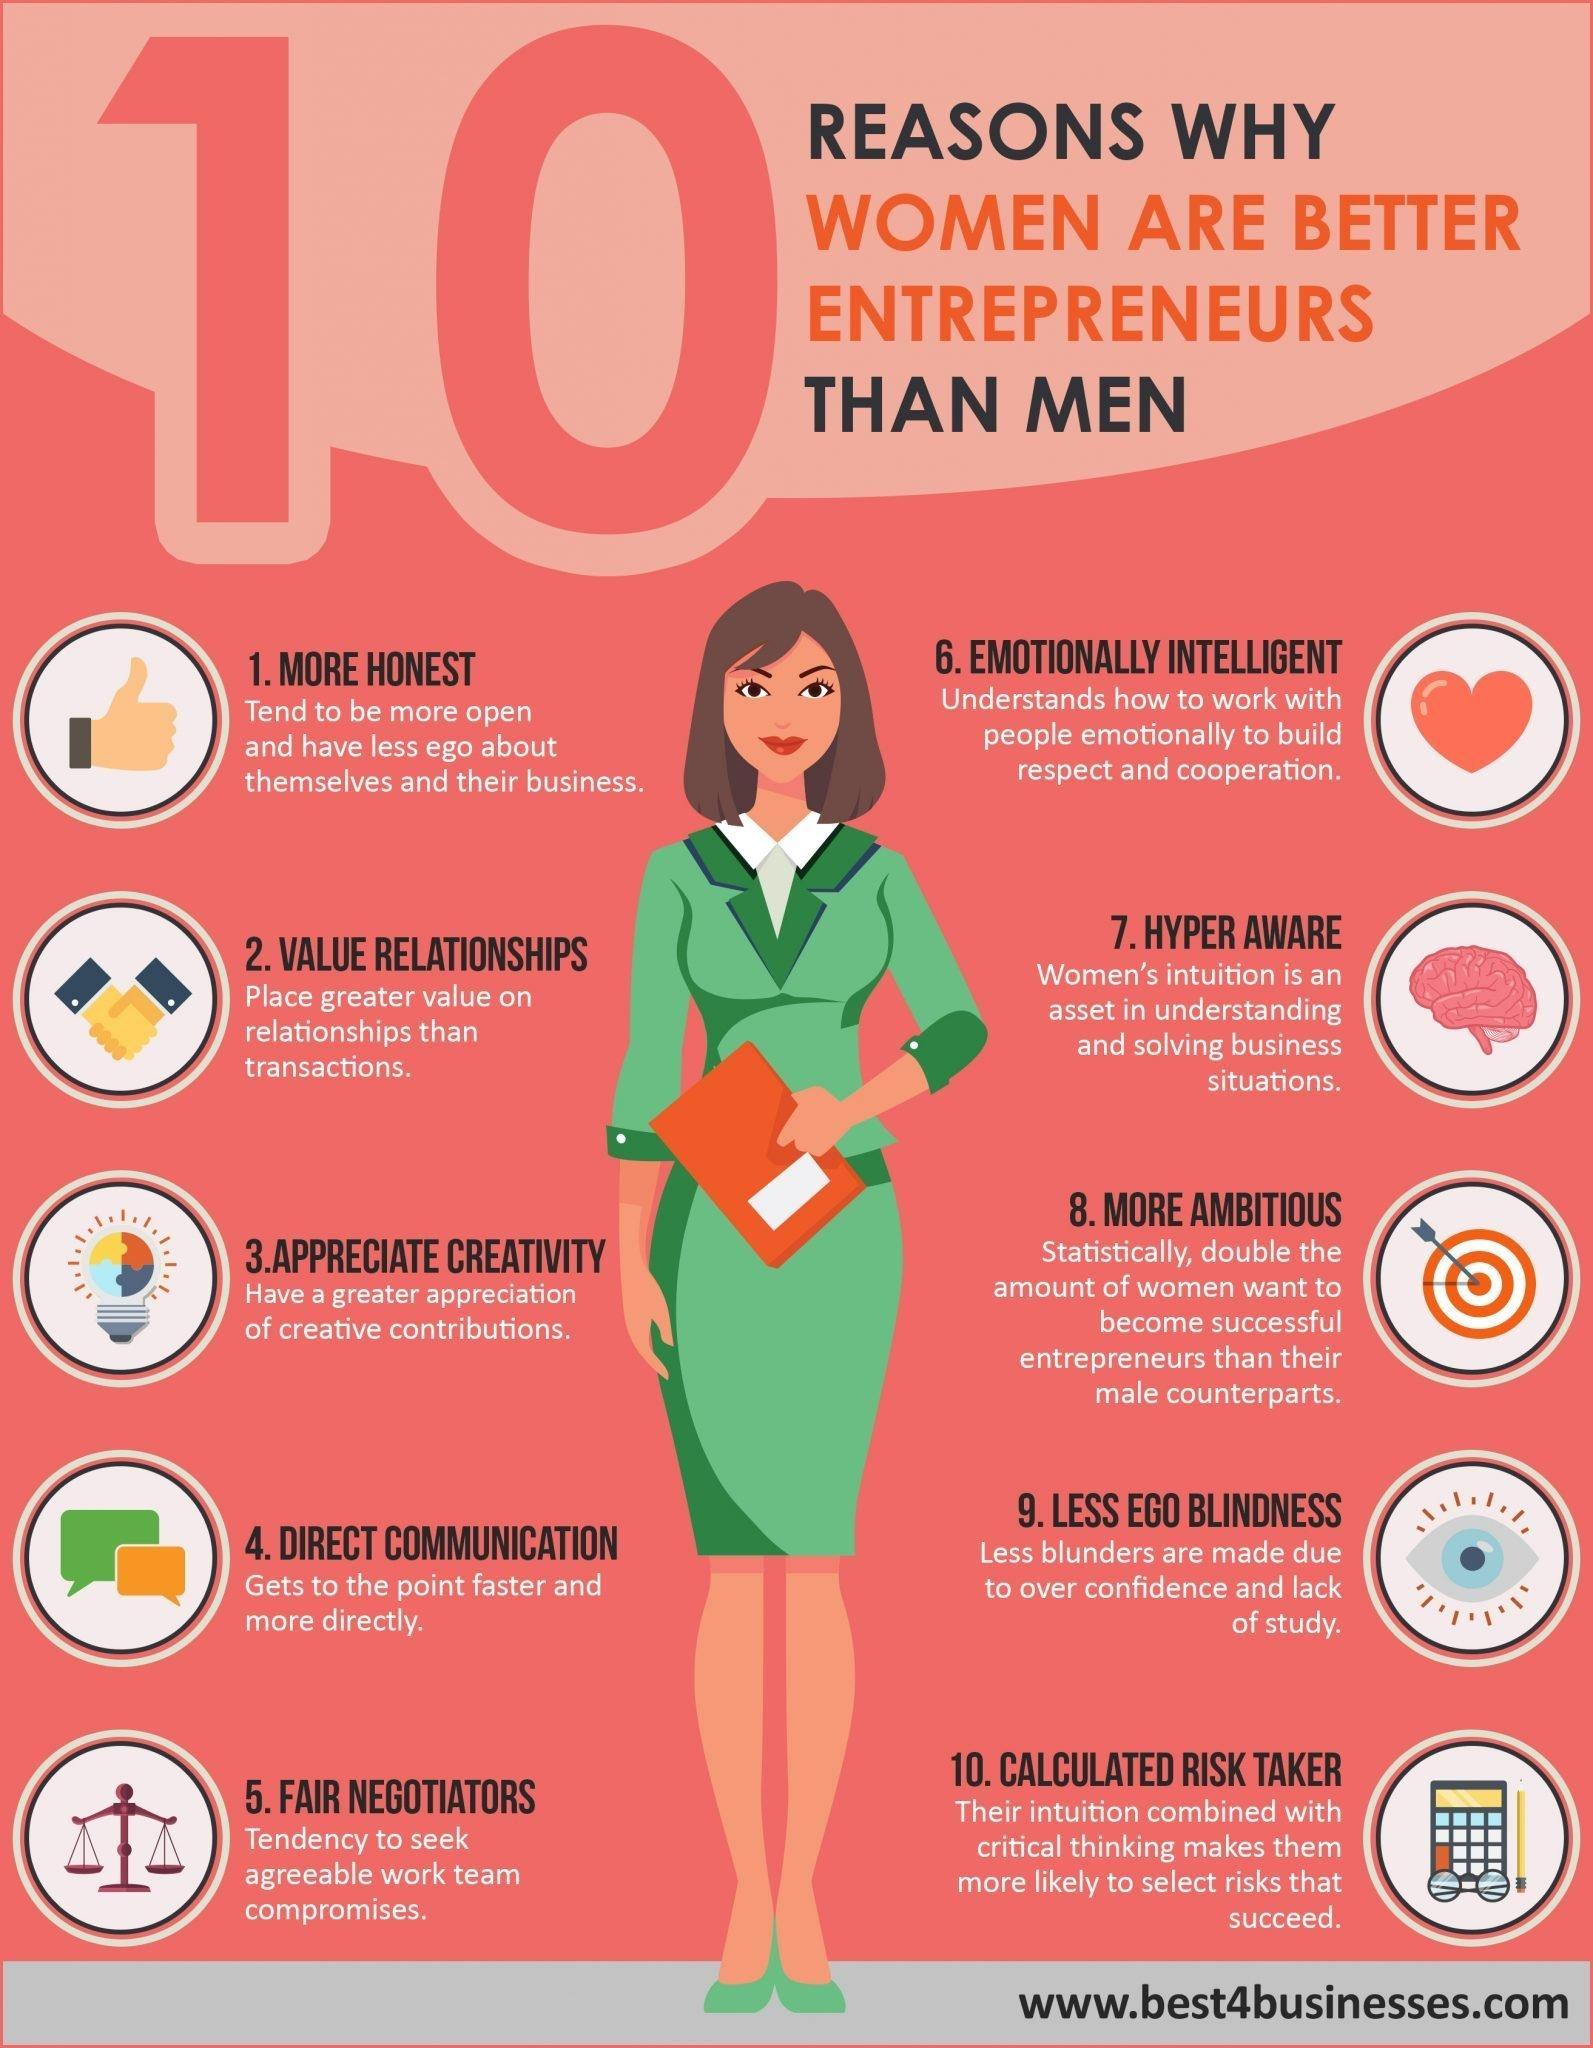Indicate a few pertinent items in this graphic. The calculator indicates that women are calculated risk-takers. The weighing scale indicates a characteristic of women that is fair negotiations. Women are generally considered to be more honest than men. The dartboard indicates that women are more ambitious than men. 